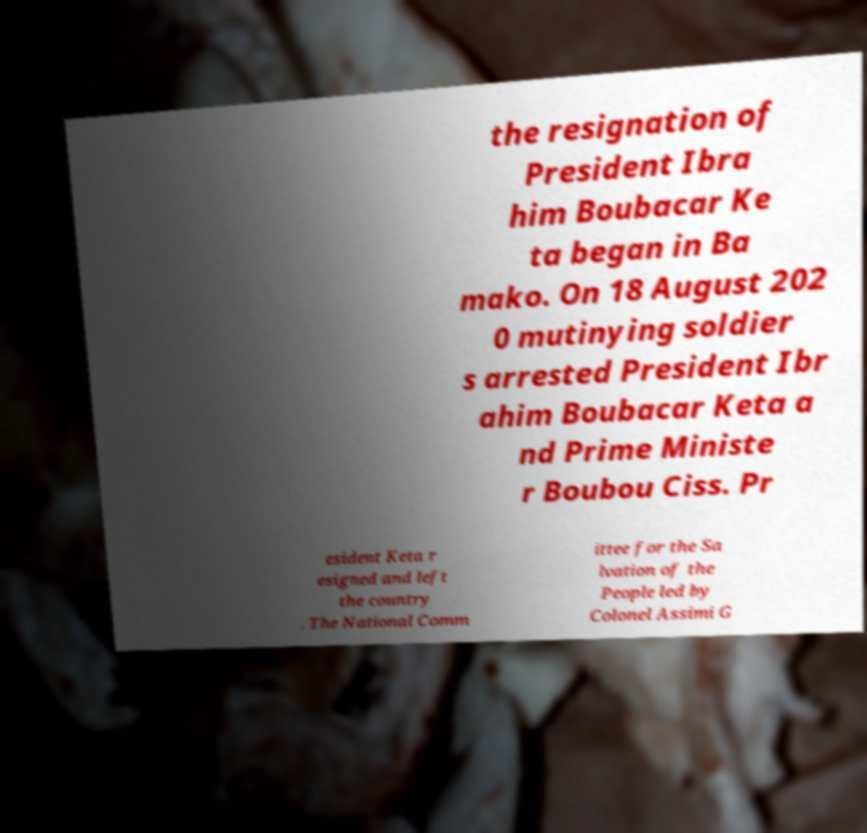For documentation purposes, I need the text within this image transcribed. Could you provide that? the resignation of President Ibra him Boubacar Ke ta began in Ba mako. On 18 August 202 0 mutinying soldier s arrested President Ibr ahim Boubacar Keta a nd Prime Ministe r Boubou Ciss. Pr esident Keta r esigned and left the country . The National Comm ittee for the Sa lvation of the People led by Colonel Assimi G 